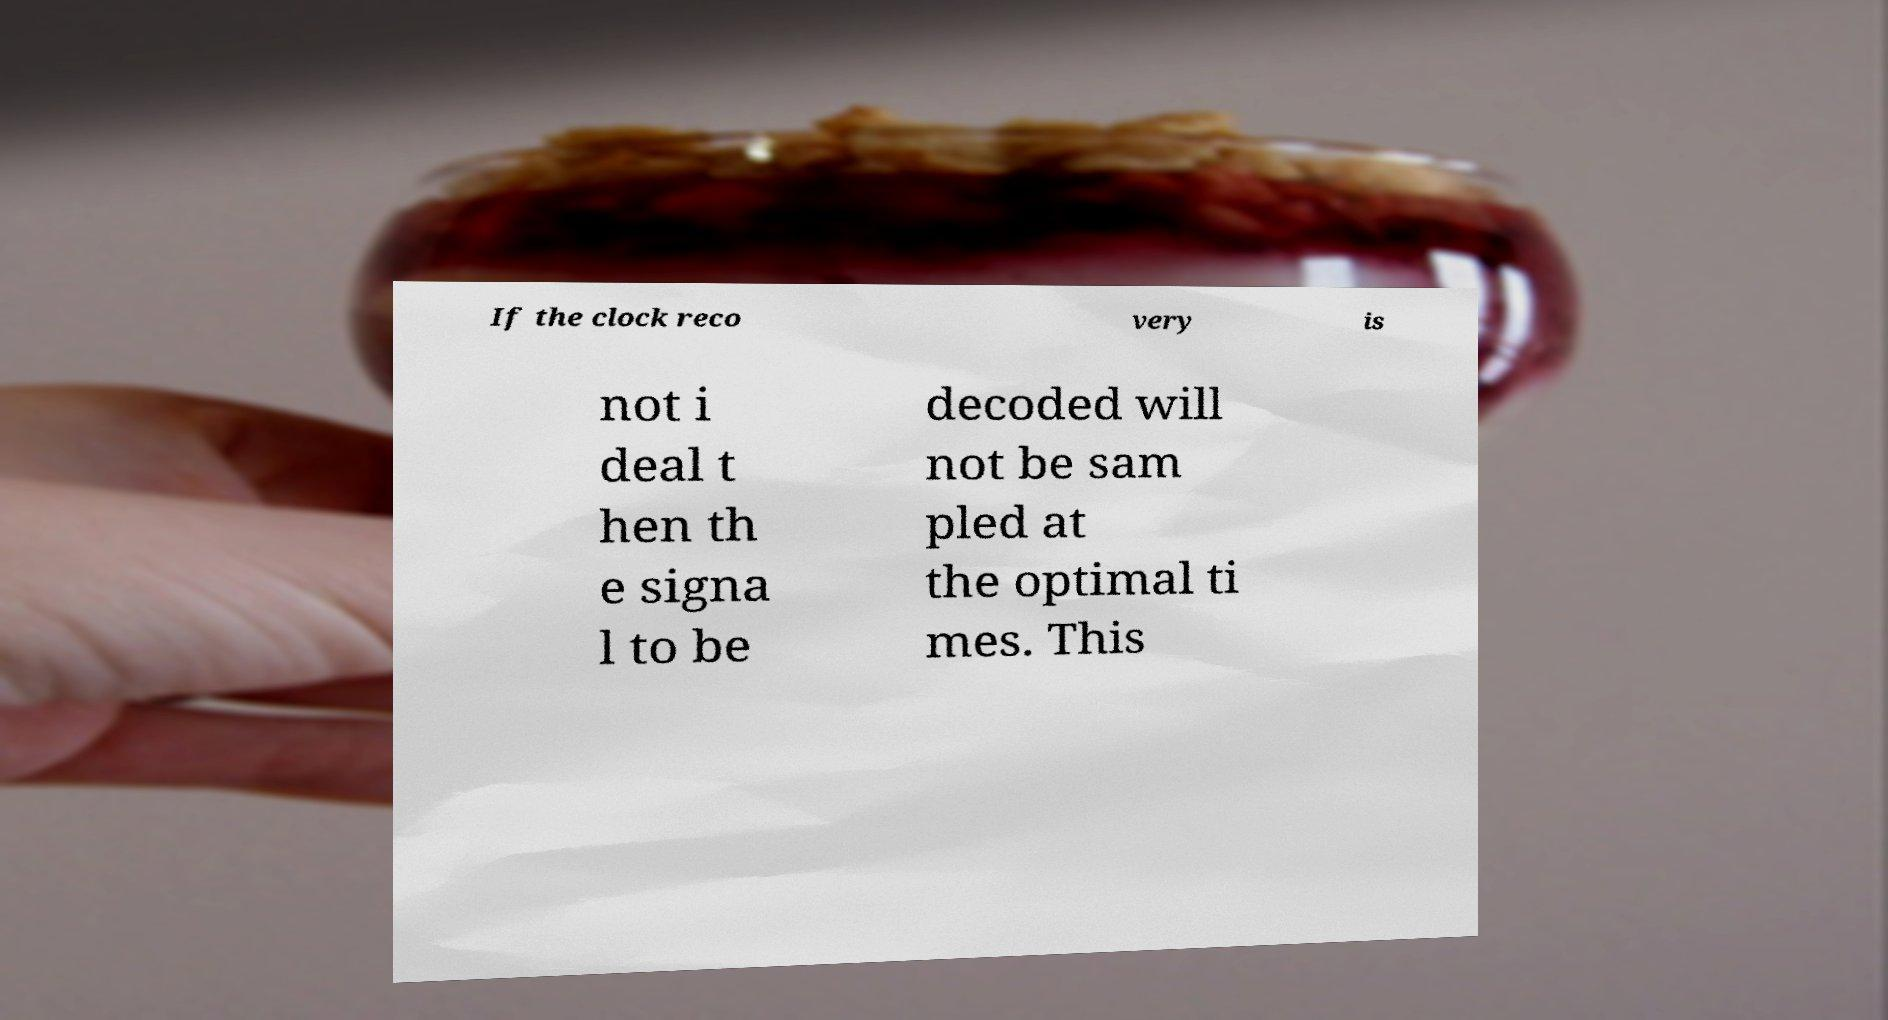Could you assist in decoding the text presented in this image and type it out clearly? If the clock reco very is not i deal t hen th e signa l to be decoded will not be sam pled at the optimal ti mes. This 